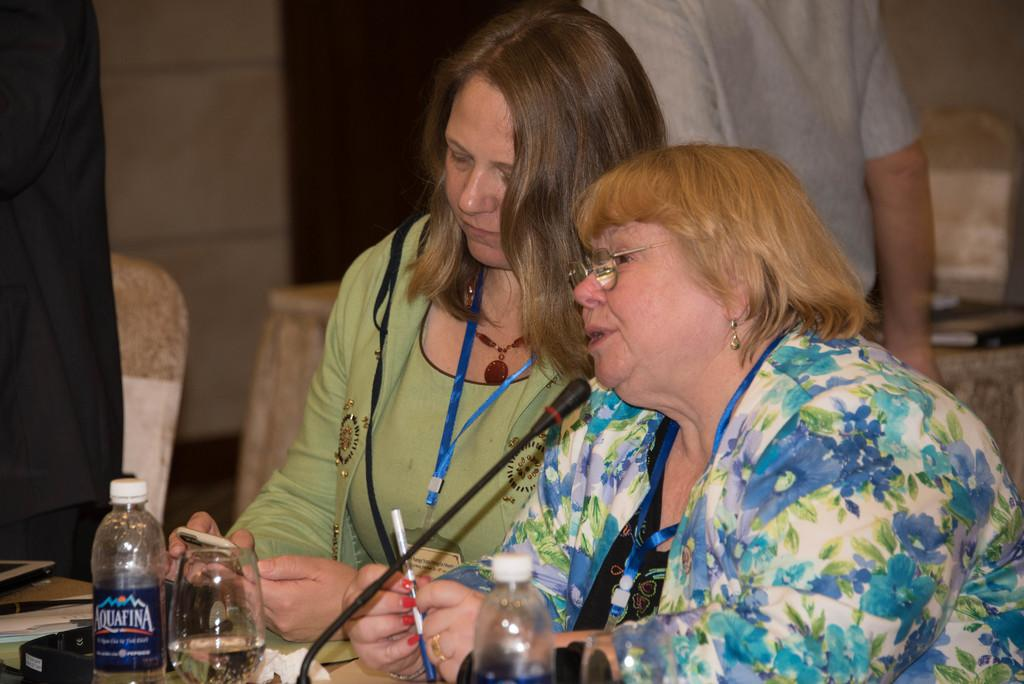How many people are in the image? There is a group of people in the image, but the exact number is not specified. What are the people in the image doing? Some people are seated, while others are standing. What can be seen on the table in the image? There are bottles, glasses, and a microphone on the table. Are there any other items on the table besides the ones mentioned? Yes, there are other unspecified items on the table. What type of appliance is being used by the guide in the image? There is no guide present in the image, and therefore no appliance being used by a guide. Can you tell me how many apples are on the table in the image? There is no mention of apples in the image, so it is not possible to determine their number. 